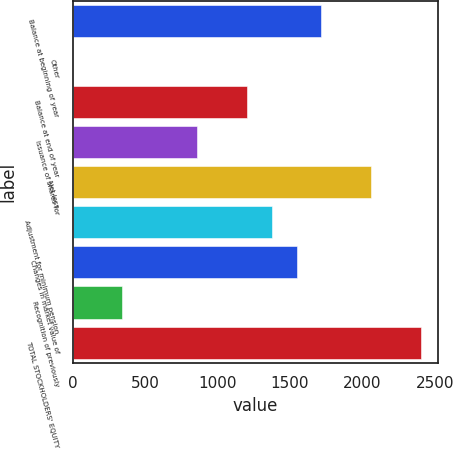Convert chart to OTSL. <chart><loc_0><loc_0><loc_500><loc_500><bar_chart><fcel>Balance at beginning of year<fcel>Other<fcel>Balance at end of year<fcel>Issuance of shares for<fcel>Net loss<fcel>Adjustment for minimum pension<fcel>Changes in market value of<fcel>Recognition of previously<fcel>TOTAL STOCKHOLDERS' EQUITY<nl><fcel>1718.3<fcel>0.7<fcel>1203.02<fcel>859.5<fcel>2061.82<fcel>1374.78<fcel>1546.54<fcel>344.22<fcel>2405.34<nl></chart> 